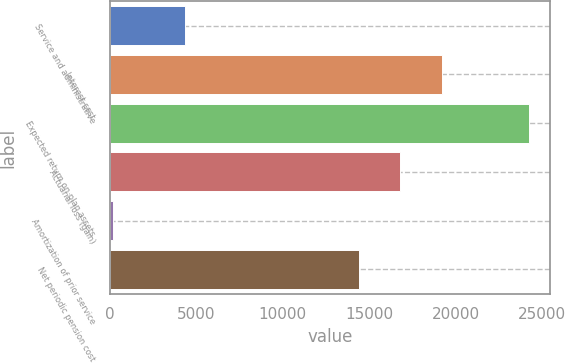<chart> <loc_0><loc_0><loc_500><loc_500><bar_chart><fcel>Service and administrative<fcel>Interest cost<fcel>Expected return on plan assets<fcel>Actuarial loss (gain)<fcel>Amortization of prior service<fcel>Net periodic pension cost<nl><fcel>4337<fcel>19217<fcel>24245<fcel>16813.5<fcel>210<fcel>14410<nl></chart> 